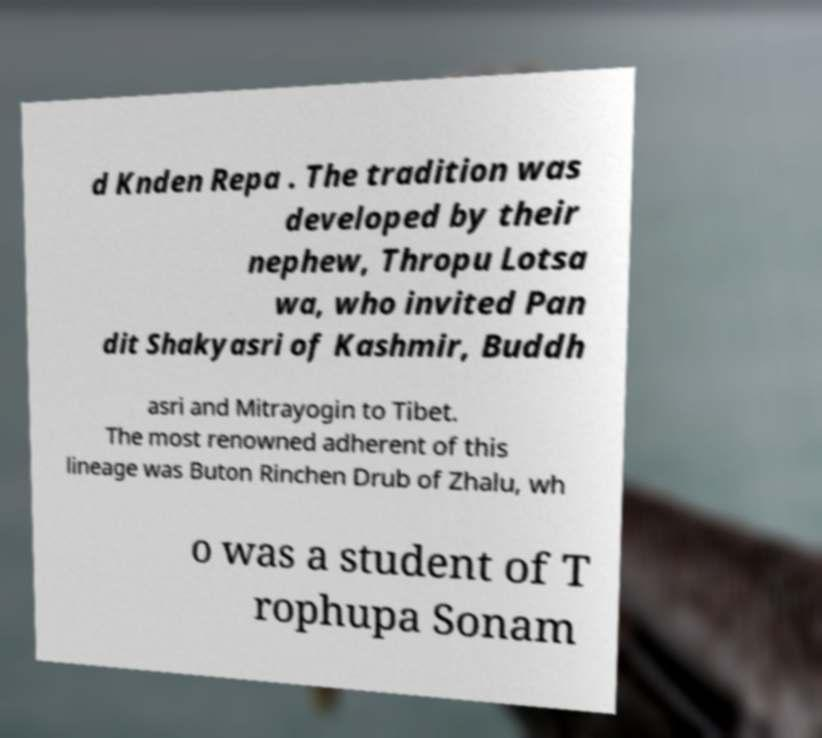What messages or text are displayed in this image? I need them in a readable, typed format. d Knden Repa . The tradition was developed by their nephew, Thropu Lotsa wa, who invited Pan dit Shakyasri of Kashmir, Buddh asri and Mitrayogin to Tibet. The most renowned adherent of this lineage was Buton Rinchen Drub of Zhalu, wh o was a student of T rophupa Sonam 